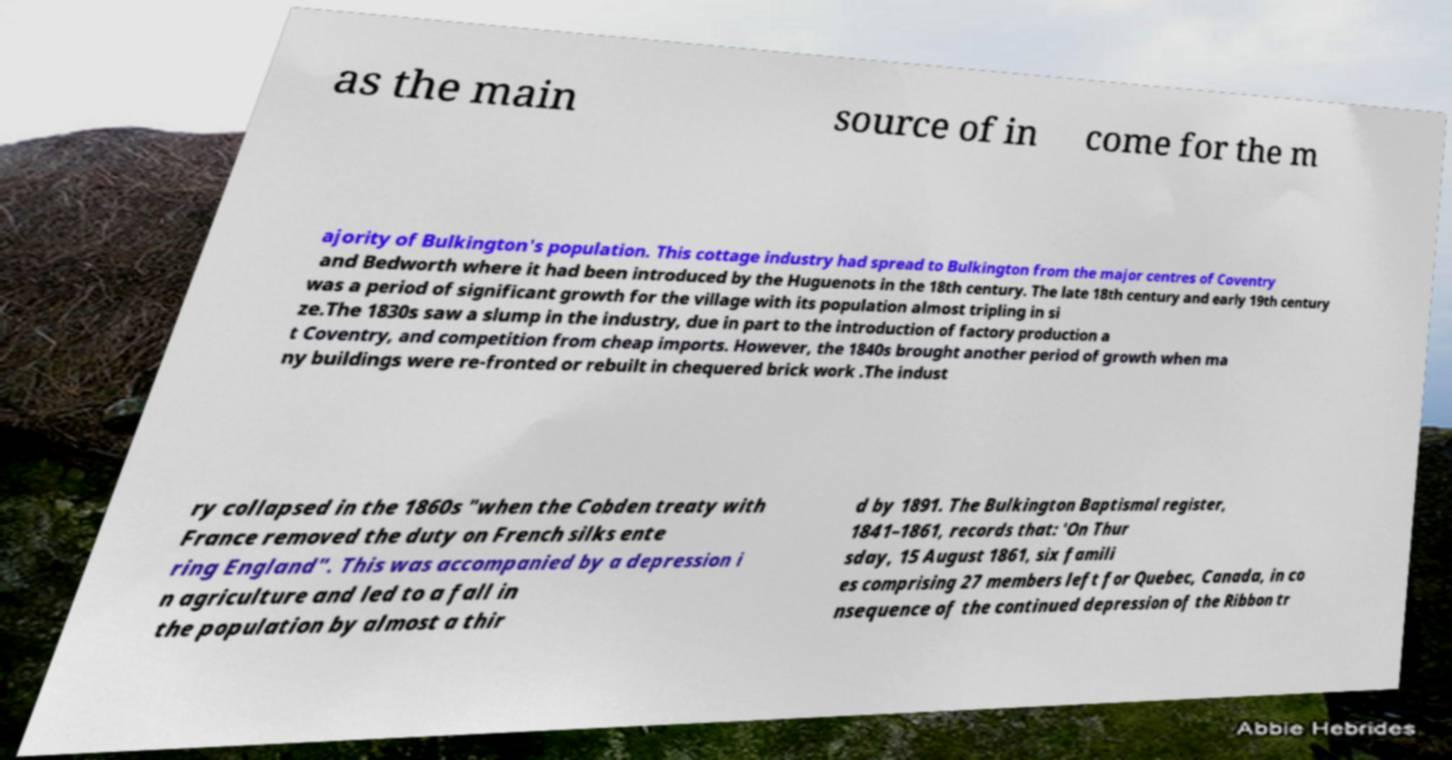I need the written content from this picture converted into text. Can you do that? as the main source of in come for the m ajority of Bulkington's population. This cottage industry had spread to Bulkington from the major centres of Coventry and Bedworth where it had been introduced by the Huguenots in the 18th century. The late 18th century and early 19th century was a period of significant growth for the village with its population almost tripling in si ze.The 1830s saw a slump in the industry, due in part to the introduction of factory production a t Coventry, and competition from cheap imports. However, the 1840s brought another period of growth when ma ny buildings were re-fronted or rebuilt in chequered brick work .The indust ry collapsed in the 1860s "when the Cobden treaty with France removed the duty on French silks ente ring England". This was accompanied by a depression i n agriculture and led to a fall in the population by almost a thir d by 1891. The Bulkington Baptismal register, 1841–1861, records that: 'On Thur sday, 15 August 1861, six famili es comprising 27 members left for Quebec, Canada, in co nsequence of the continued depression of the Ribbon tr 